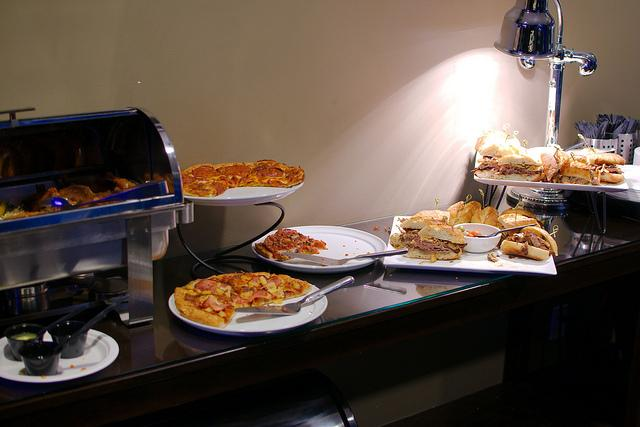What kind of service was this?

Choices:
A) catering
B) delivery
C) home made
D) restaurant catering 